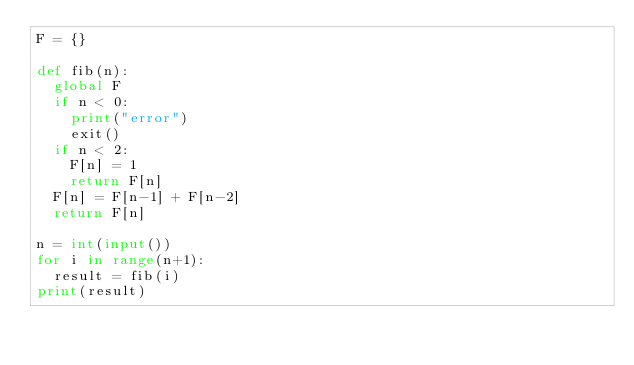Convert code to text. <code><loc_0><loc_0><loc_500><loc_500><_Python_>F = {}

def fib(n):
  global F
  if n < 0:
    print("error")
    exit()
  if n < 2:
    F[n] = 1
    return F[n]
  F[n] = F[n-1] + F[n-2]
  return F[n]

n = int(input())
for i in range(n+1):
  result = fib(i)
print(result)</code> 